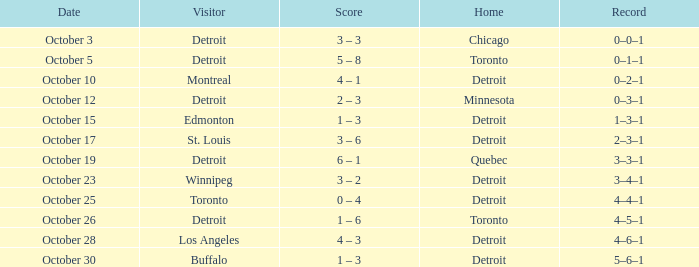Name the home with toronto visiting Detroit. 